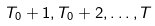Convert formula to latex. <formula><loc_0><loc_0><loc_500><loc_500>T _ { 0 } + 1 , T _ { 0 } + 2 , \dots , T</formula> 